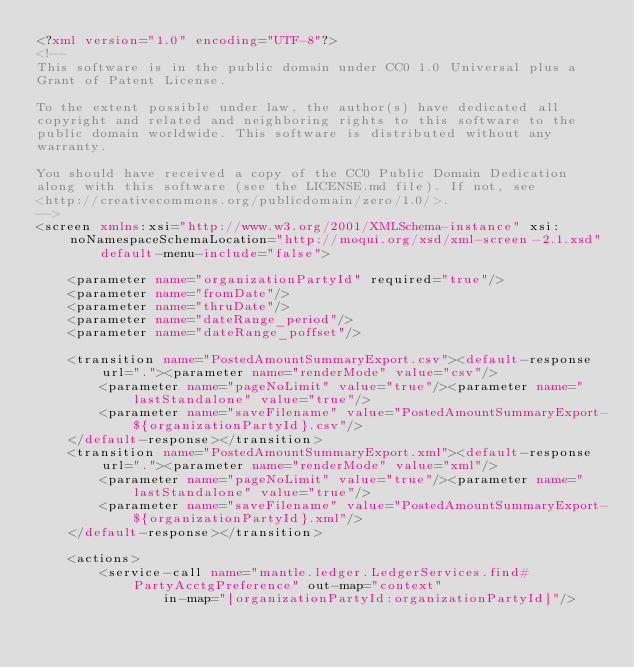Convert code to text. <code><loc_0><loc_0><loc_500><loc_500><_XML_><?xml version="1.0" encoding="UTF-8"?>
<!--
This software is in the public domain under CC0 1.0 Universal plus a
Grant of Patent License.

To the extent possible under law, the author(s) have dedicated all
copyright and related and neighboring rights to this software to the
public domain worldwide. This software is distributed without any
warranty.

You should have received a copy of the CC0 Public Domain Dedication
along with this software (see the LICENSE.md file). If not, see
<http://creativecommons.org/publicdomain/zero/1.0/>.
-->
<screen xmlns:xsi="http://www.w3.org/2001/XMLSchema-instance" xsi:noNamespaceSchemaLocation="http://moqui.org/xsd/xml-screen-2.1.xsd"
        default-menu-include="false">

    <parameter name="organizationPartyId" required="true"/>
    <parameter name="fromDate"/>
    <parameter name="thruDate"/>
    <parameter name="dateRange_period"/>
    <parameter name="dateRange_poffset"/>

    <transition name="PostedAmountSummaryExport.csv"><default-response url="."><parameter name="renderMode" value="csv"/>
        <parameter name="pageNoLimit" value="true"/><parameter name="lastStandalone" value="true"/>
        <parameter name="saveFilename" value="PostedAmountSummaryExport-${organizationPartyId}.csv"/>
    </default-response></transition>
    <transition name="PostedAmountSummaryExport.xml"><default-response url="."><parameter name="renderMode" value="xml"/>
        <parameter name="pageNoLimit" value="true"/><parameter name="lastStandalone" value="true"/>
        <parameter name="saveFilename" value="PostedAmountSummaryExport-${organizationPartyId}.xml"/>
    </default-response></transition>

    <actions>
        <service-call name="mantle.ledger.LedgerServices.find#PartyAcctgPreference" out-map="context"
                in-map="[organizationPartyId:organizationPartyId]"/>
</code> 